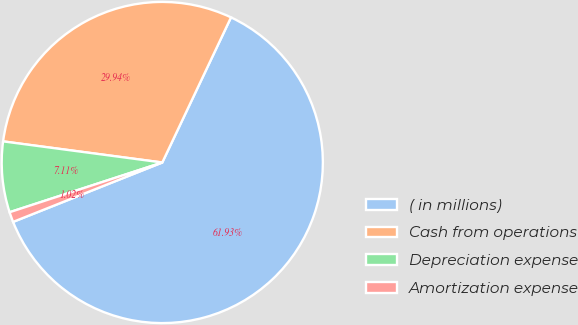<chart> <loc_0><loc_0><loc_500><loc_500><pie_chart><fcel>( in millions)<fcel>Cash from operations<fcel>Depreciation expense<fcel>Amortization expense<nl><fcel>61.93%<fcel>29.94%<fcel>7.11%<fcel>1.02%<nl></chart> 